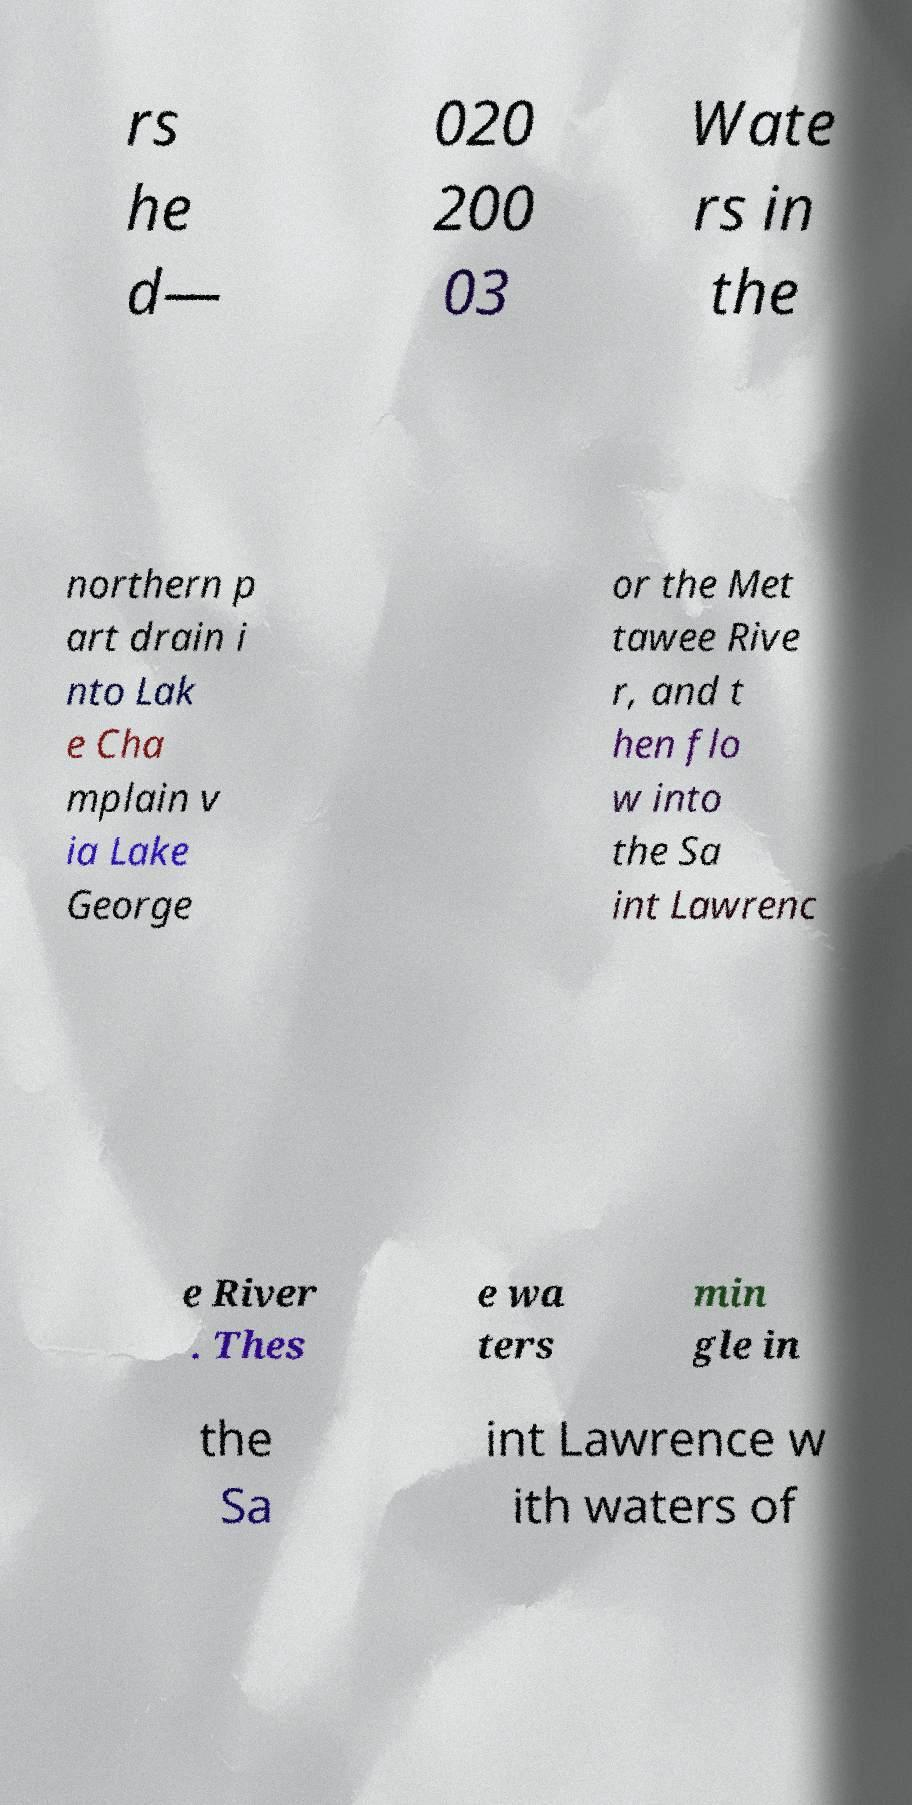Could you assist in decoding the text presented in this image and type it out clearly? rs he d— 020 200 03 Wate rs in the northern p art drain i nto Lak e Cha mplain v ia Lake George or the Met tawee Rive r, and t hen flo w into the Sa int Lawrenc e River . Thes e wa ters min gle in the Sa int Lawrence w ith waters of 